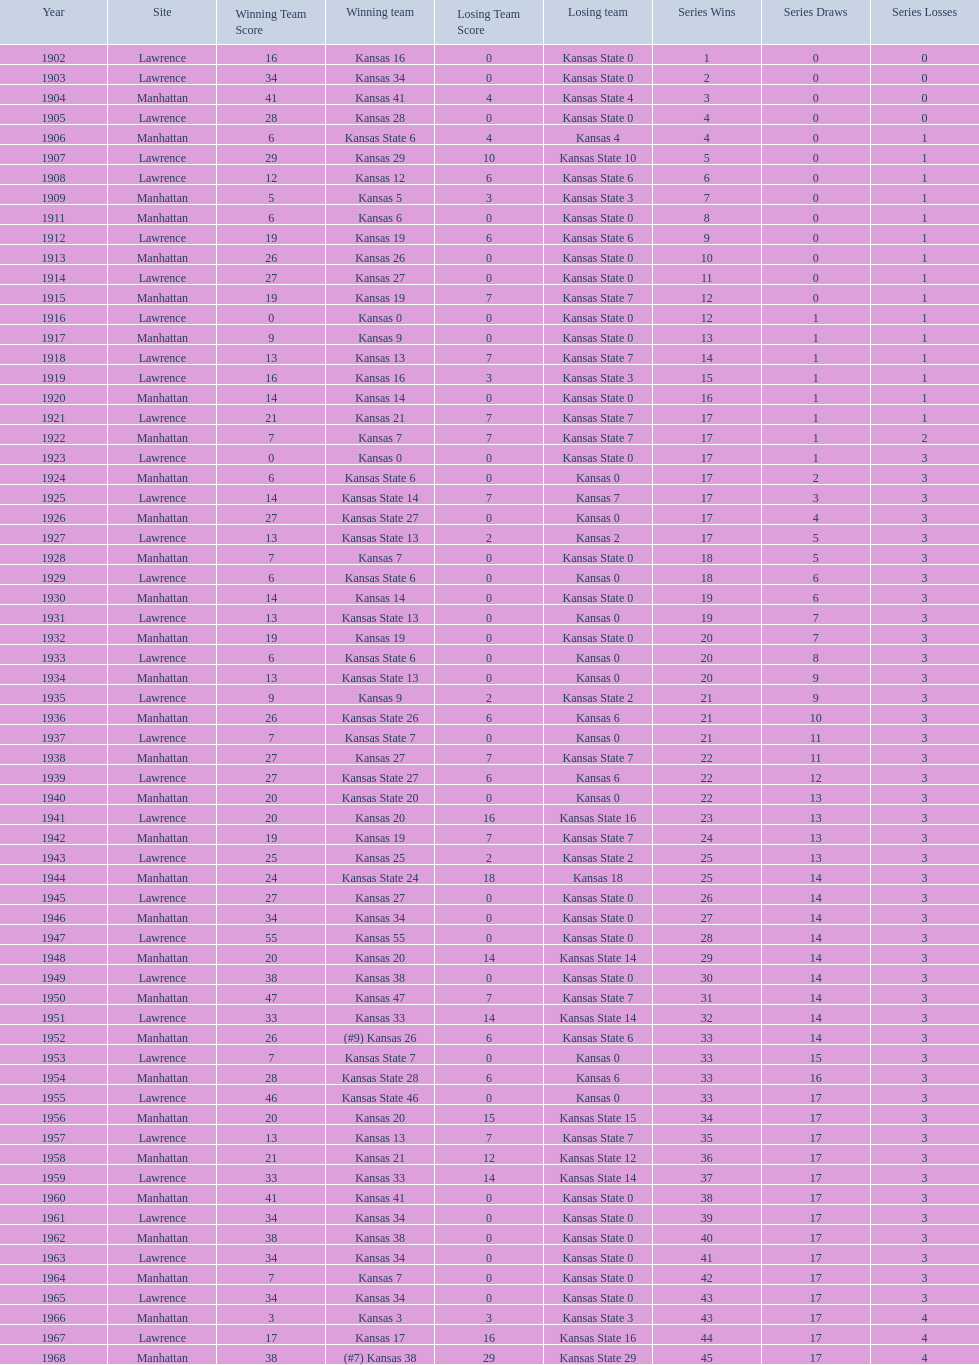What is the total number of games played? 66. 